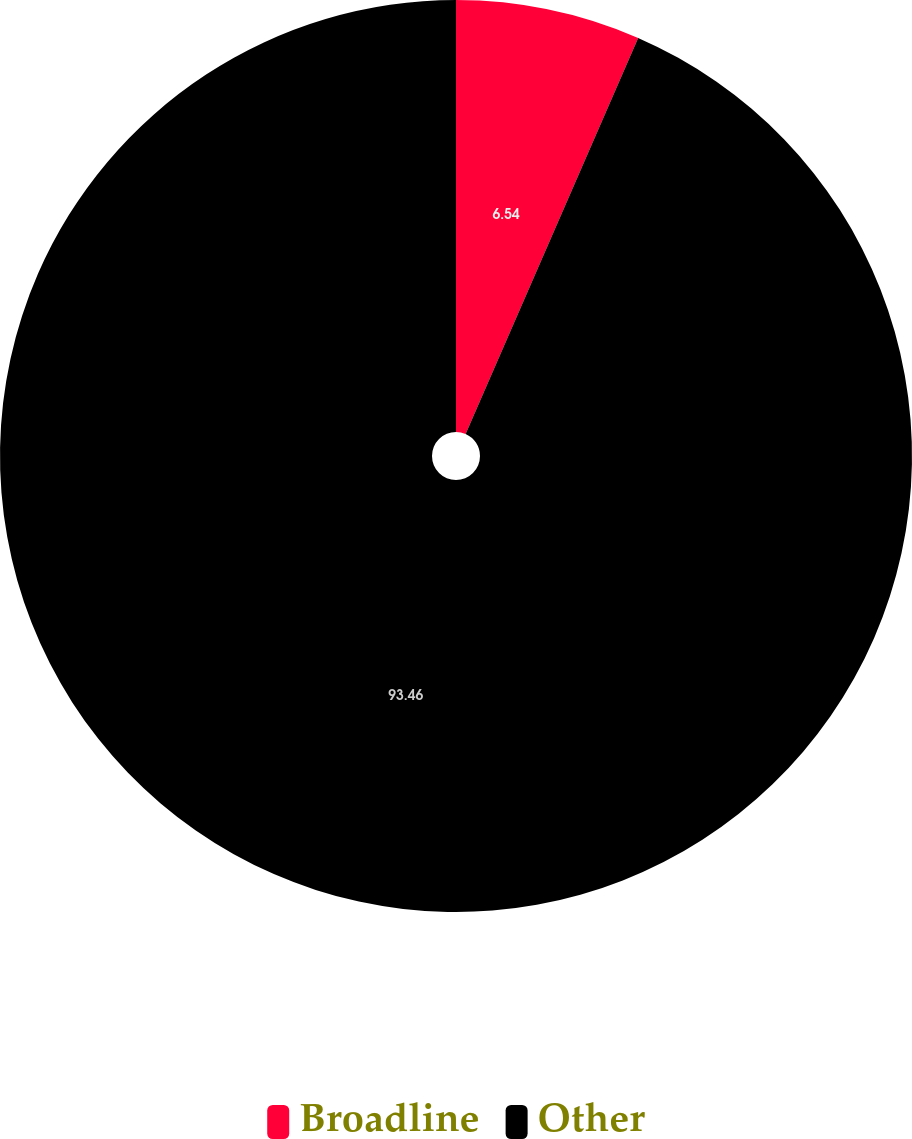Convert chart to OTSL. <chart><loc_0><loc_0><loc_500><loc_500><pie_chart><fcel>Broadline<fcel>Other<nl><fcel>6.54%<fcel>93.46%<nl></chart> 